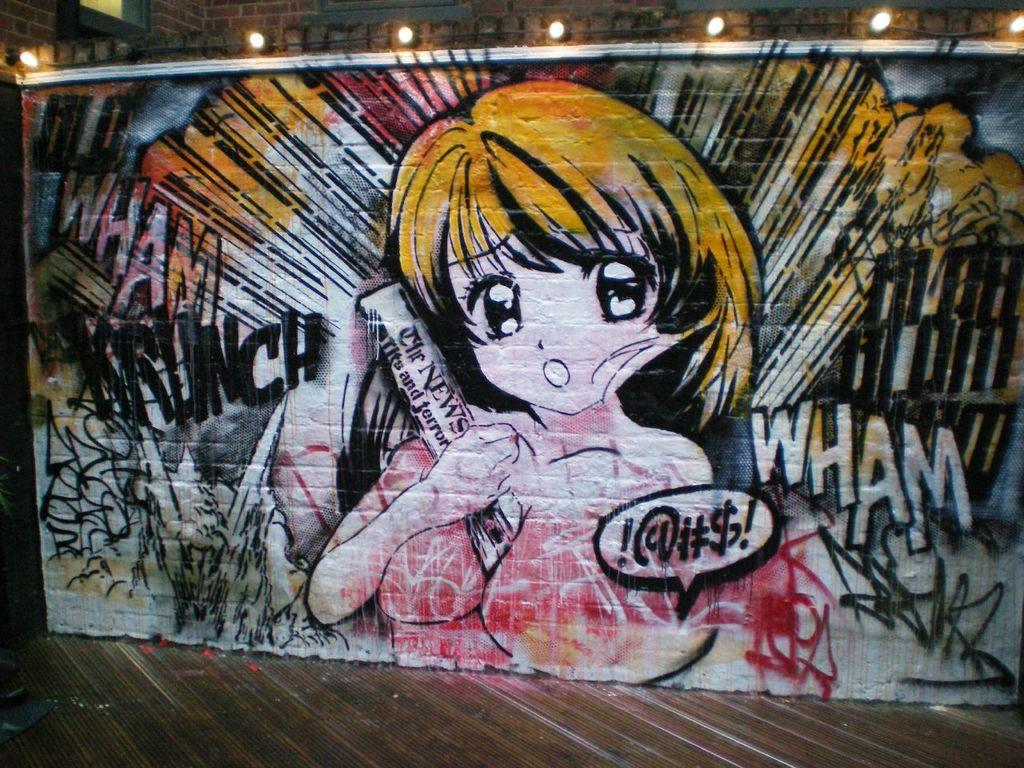What type of artwork is on the wall in the image? There is a cartoon painted on the wall in the image. What can be seen illuminating the room in the image? There are lights visible in the image. What surface is present under the people and objects in the image? The floor is present in the image. What type of fruit is being used to pay for the items in the image? There is no fruit or payment being depicted in the image; it only features a cartoon painted on the wall, lights, and the floor. 